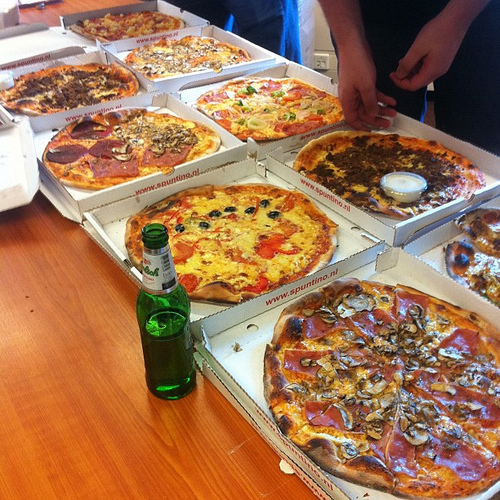Is there a cup to the left of the cheese in the container? No, there is no cup to the left of the cheese in the container. 